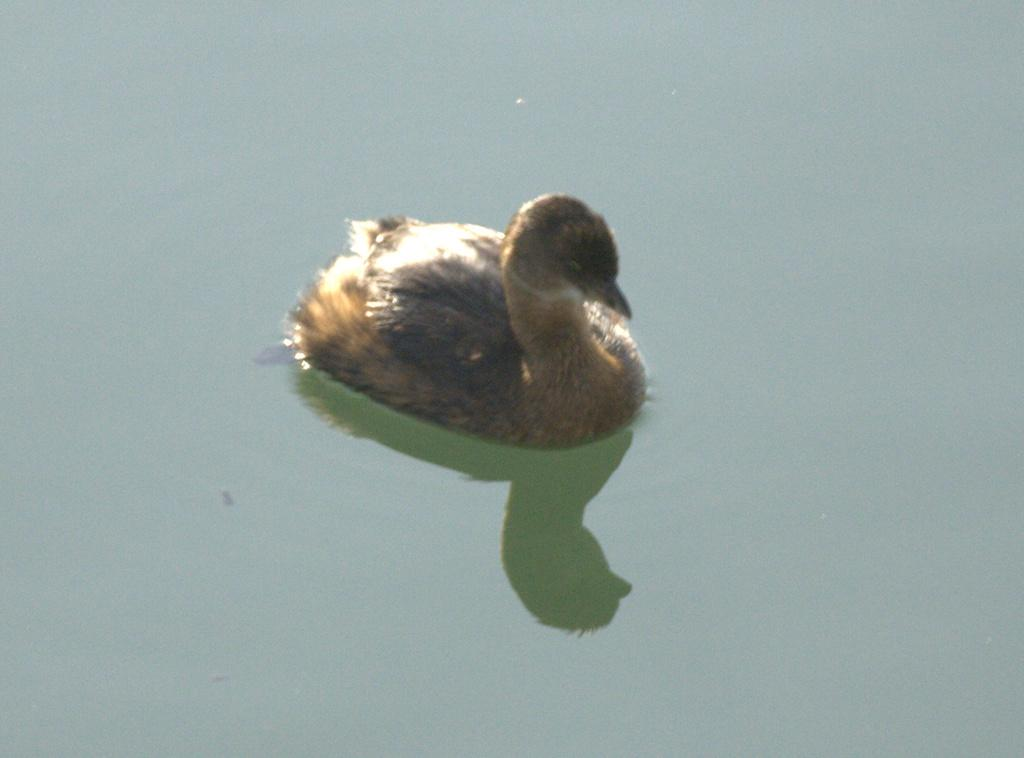What animal is present in the image? There is a duck in the image. Where is the duck located? The duck is in the water. What type of cave can be seen in the background of the image? There is no cave present in the image; it features a duck in the water. 